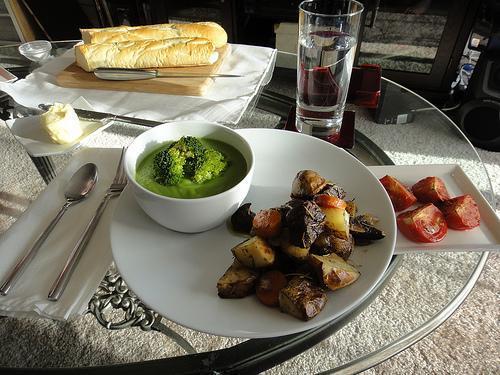How many glasses are on the table?
Give a very brief answer. 1. 